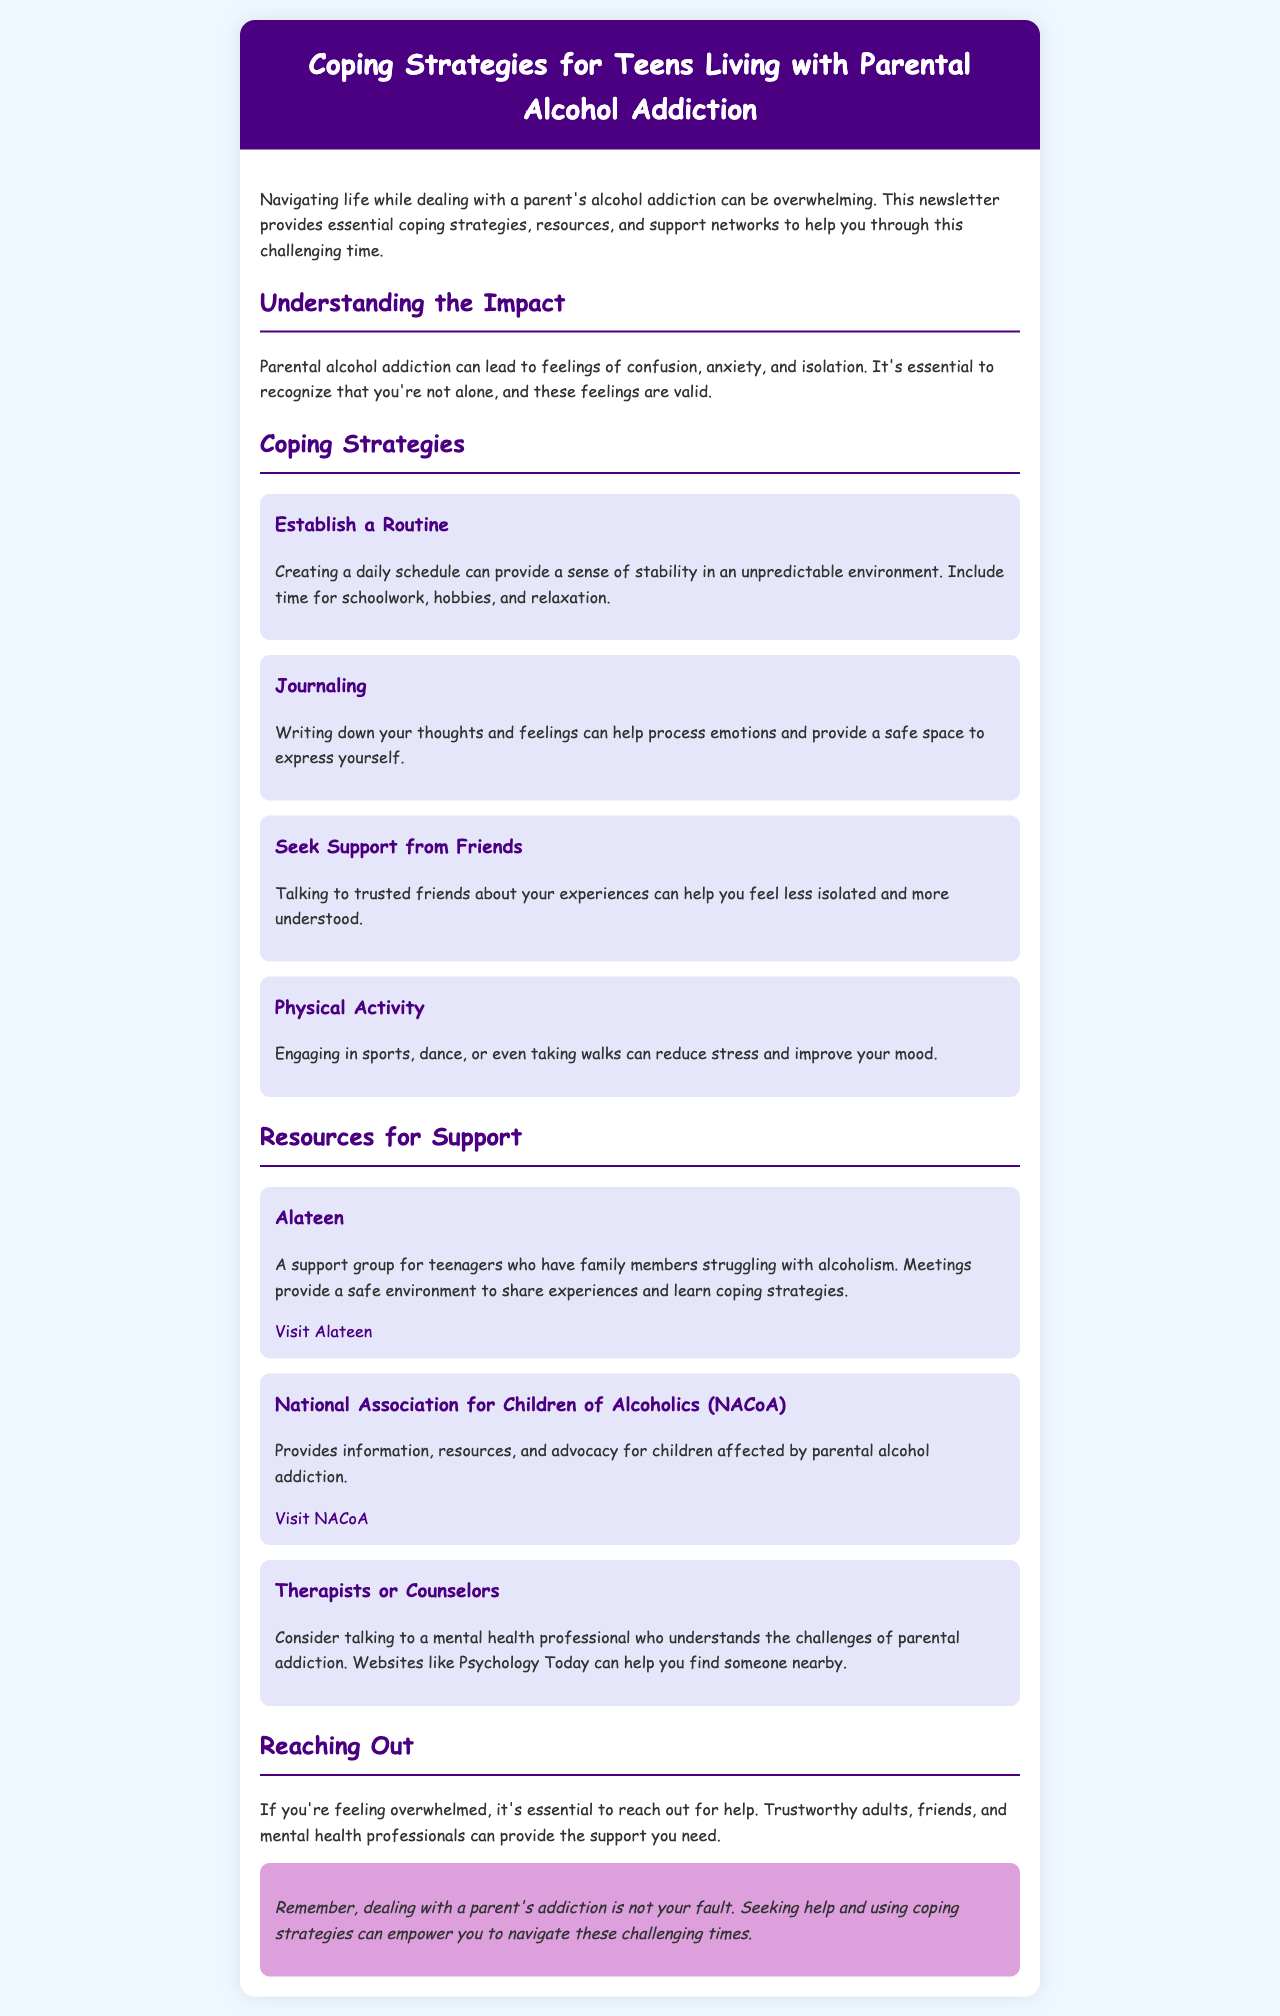What is the title of the newsletter? The title of the newsletter is mentioned at the top of the document.
Answer: Coping Strategies for Teens Living with Parental Alcohol Addiction What is one coping strategy mentioned in the newsletter? The newsletter lists several coping strategies designed to help teens, one of which can be selected as an example.
Answer: Establish a Routine What organization provides support specifically for teenagers with family members struggling with alcoholism? The newsletter identifies a specific organization that caters to teens in this situation.
Answer: Alateen What color is used for the header background? The header of the newsletter has a distinct color that is specified in the design.
Answer: Dark purple How can physical activity help teens coping with parental alcohol addiction? The newsletter explains the benefits of physical activity on mood and stress levels as a coping strategy.
Answer: Reduces stress What is one type of professional recommended for seeking support? The document mentions several types of professionals, focusing particularly on mental health support.
Answer: Therapists or Counselors What should teens do if they are feeling overwhelmed? The newsletter suggests taking specific actions when feeling overwhelmed by the situation.
Answer: Reach out for help How does the document recommend dealing with emotions? The newsletter includes a recommendation on managing and processing feelings, which is an important coping mechanism.
Answer: Journaling 